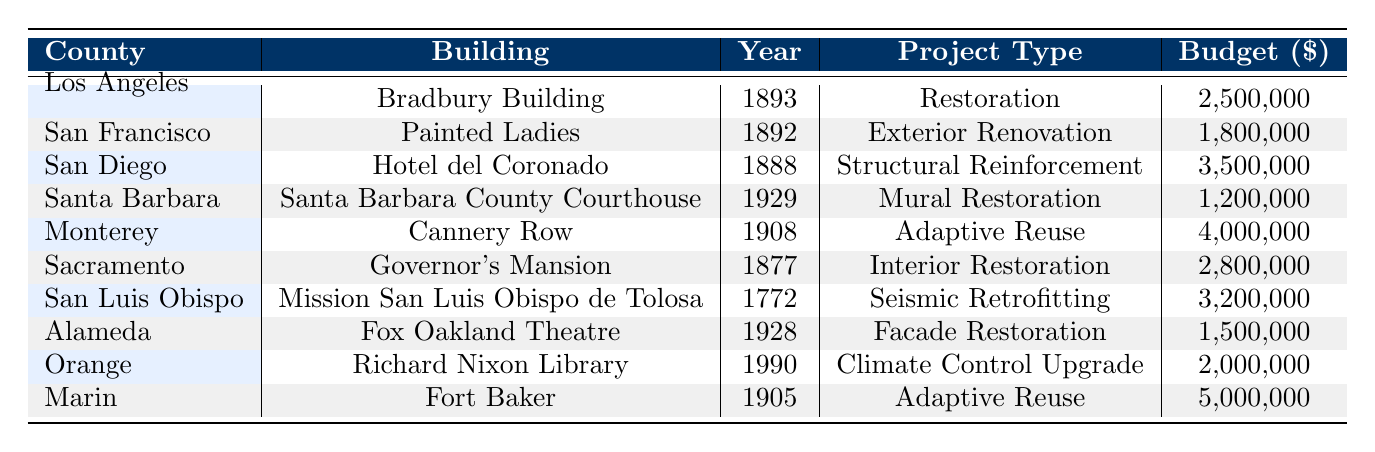What is the budget for the restoration of the Bradbury Building? The budget for the Bradbury Building project listed under the Los Angeles County row is $2,500,000.
Answer: 2,500,000 Which preservation organization worked on the Painted Ladies? The organization noted for working on the Painted Ladies in San Francisco is San Francisco Heritage.
Answer: San Francisco Heritage What type of project was the Hotel del Coronado involved in? Looking at the row for the Hotel del Coronado in San Diego, the project type is listed as Structural Reinforcement.
Answer: Structural Reinforcement How many buildings mentioned had an architectural style of Adaptive Reuse? By examining the table, the buildings classified under Adaptive Reuse are Cannery Row and Fort Baker. Therefore, there are two projects of this style.
Answer: 2 Which county had the largest project budget, and what was that budget? The largest project budget is from Marin County for Fort Baker, which amounts to $5,000,000.
Answer: Marin County, 5,000,000 Is the completion year for the Governor's Mansion project before or after 2020? The completion year for the Governor's Mansion project is 2017, which is before the year 2020.
Answer: Before What is the average budget for all the projects listed? Summing all project budgets: 2,500,000 + 1,800,000 + 3,500,000 + 1,200,000 + 4,000,000 + 2,800,000 + 3,200,000 + 1,500,000 + 2,000,000 + 5,000,000 gives a total of 23,500,000. There are 10 projects, so the average budget is 23,500,000 / 10 = 2,350,000.
Answer: 2,350,000 Did any building restoration projects occur in the year 2023? The only project that completed in 2023 is for Mission San Luis Obispo de Tolosa in San Luis Obispo County, confirming that there was a project in this year.
Answer: Yes Which building restoration took place in the county with the oldest building listed? Mission San Luis Obispo de Tolosa in San Luis Obispo County was completed in 2023 and is the project associated with the oldest building, built in 1772.
Answer: Mission San Luis Obispo de Tolosa 